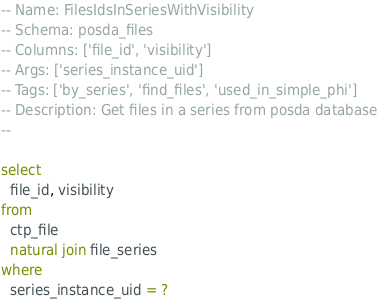<code> <loc_0><loc_0><loc_500><loc_500><_SQL_>-- Name: FilesIdsInSeriesWithVisibility
-- Schema: posda_files
-- Columns: ['file_id', 'visibility']
-- Args: ['series_instance_uid']
-- Tags: ['by_series', 'find_files', 'used_in_simple_phi']
-- Description: Get files in a series from posda database
-- 

select
  file_id, visibility
from
  ctp_file
  natural join file_series
where
  series_instance_uid = ?
</code> 